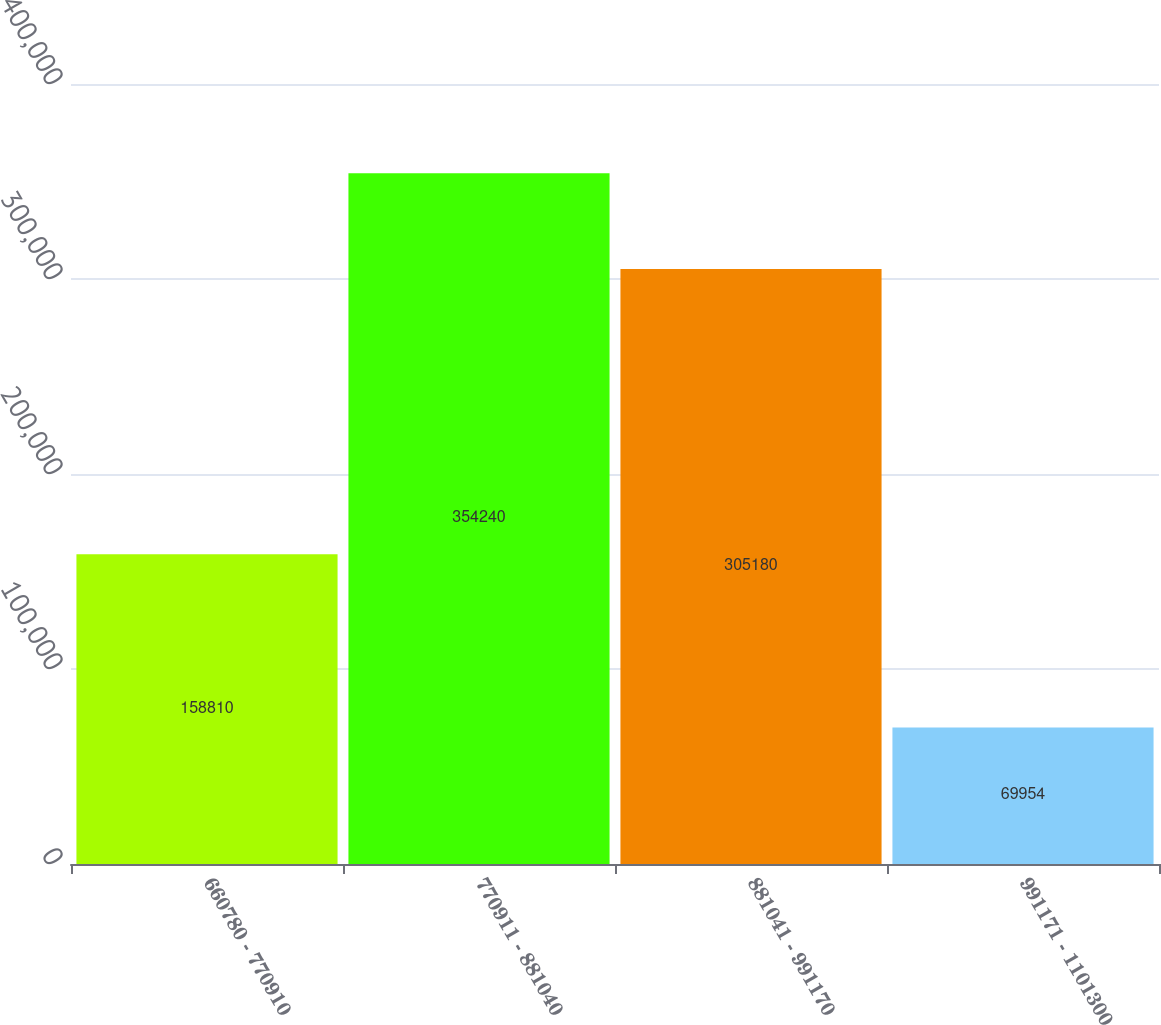Convert chart to OTSL. <chart><loc_0><loc_0><loc_500><loc_500><bar_chart><fcel>660780 - 770910<fcel>770911 - 881040<fcel>881041 - 991170<fcel>991171 - 1101300<nl><fcel>158810<fcel>354240<fcel>305180<fcel>69954<nl></chart> 